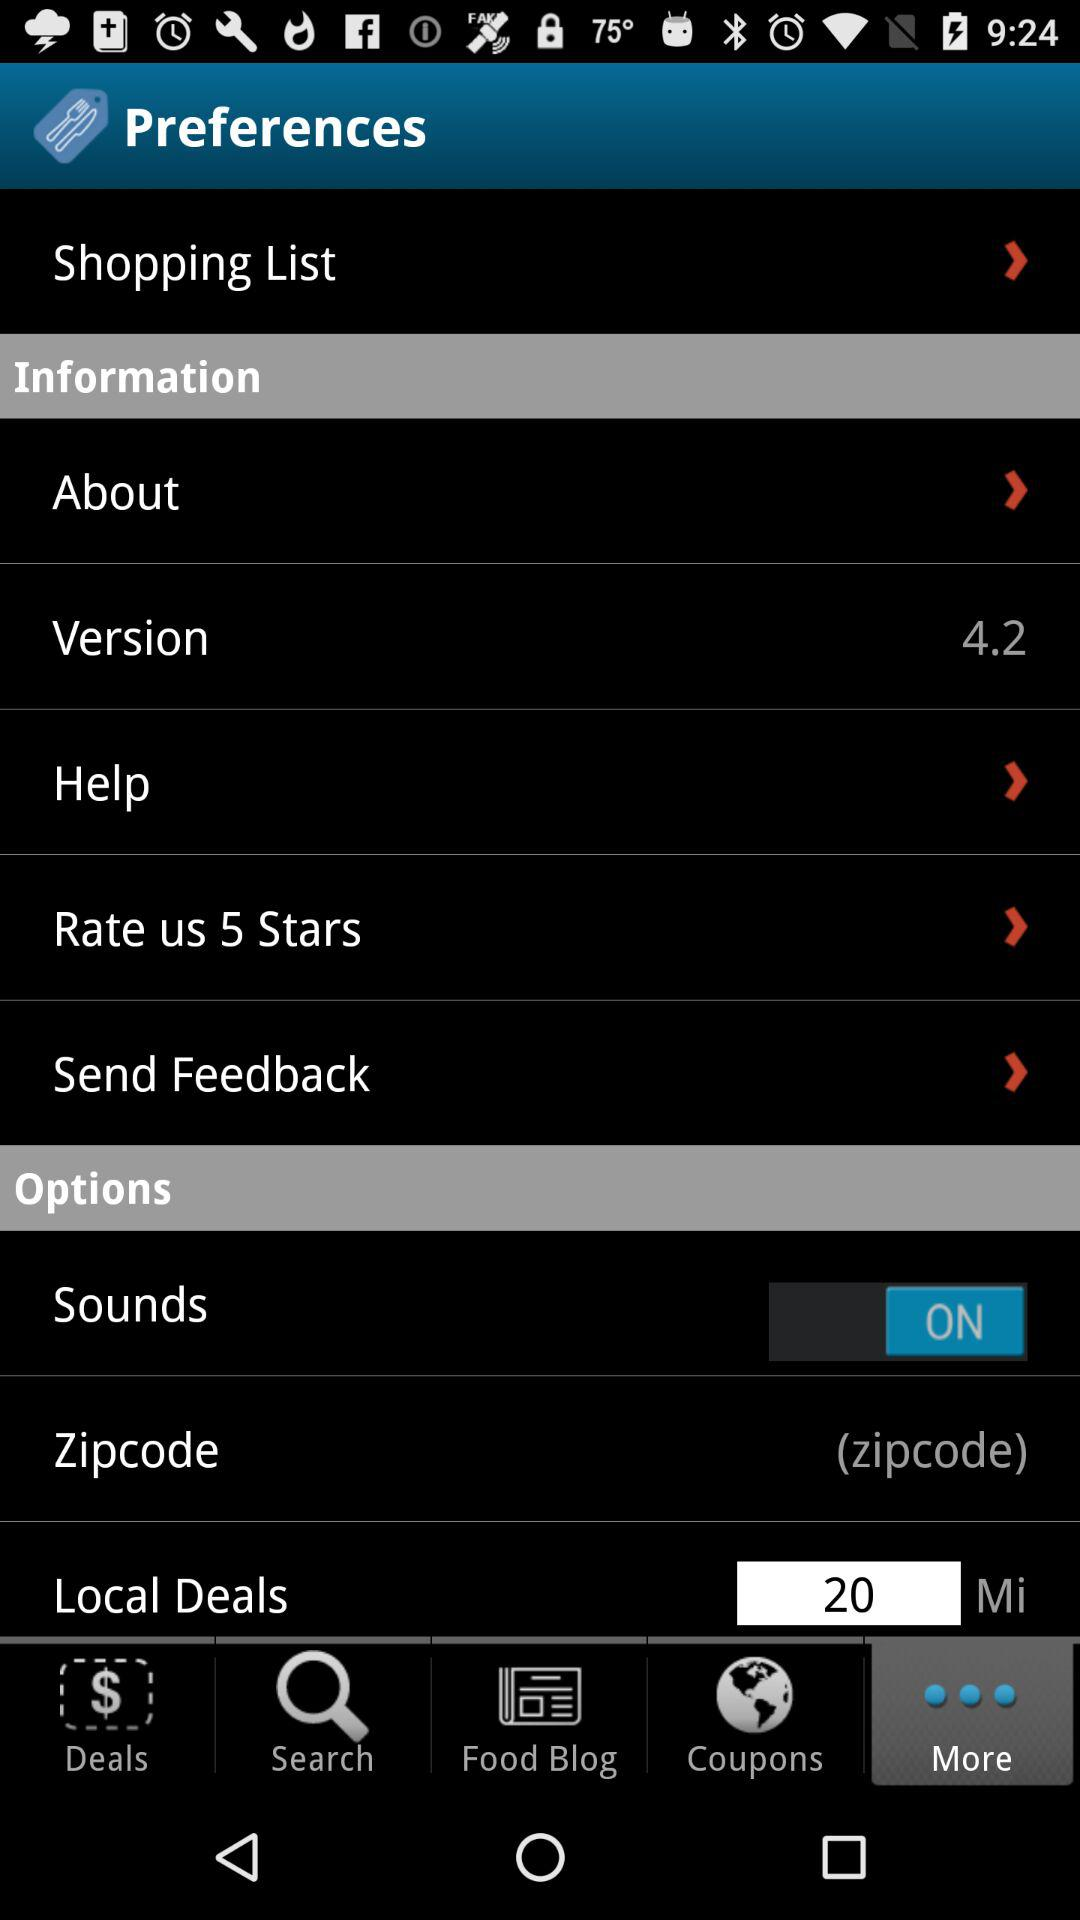Which tab has selected? The selected tab is More. 